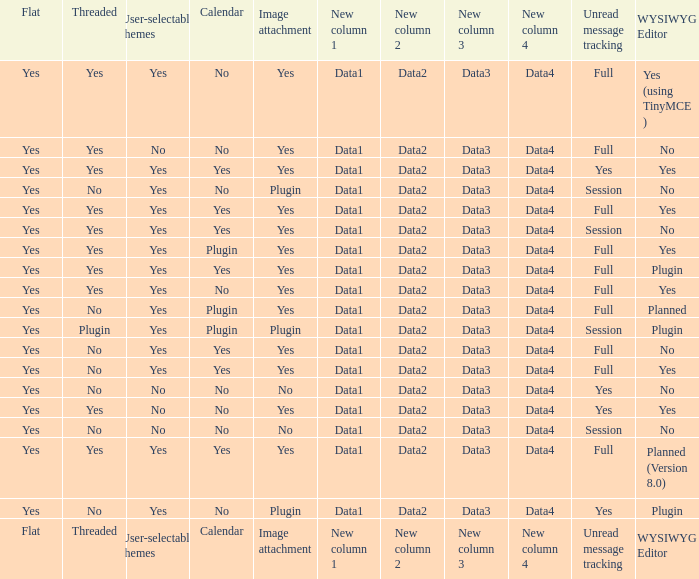Which Calendar has a WYSIWYG Editor of no, and an Unread message tracking of session, and an Image attachment of no? No. 